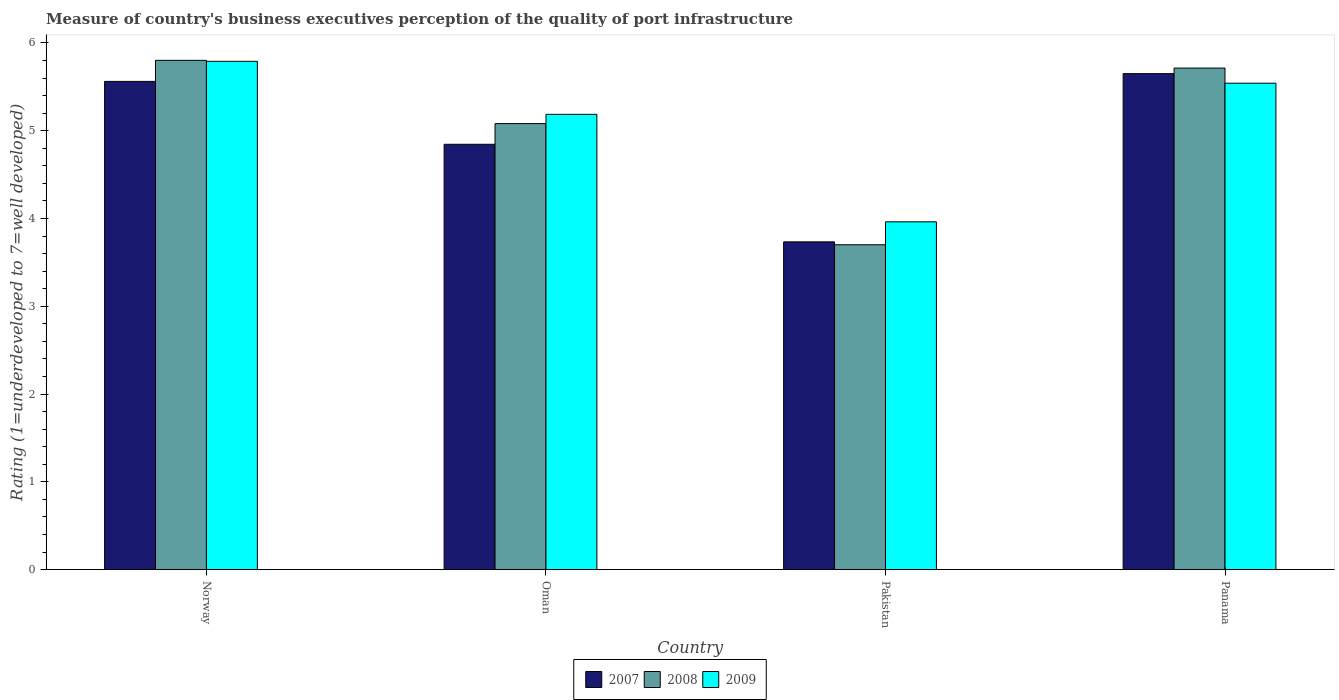Are the number of bars on each tick of the X-axis equal?
Provide a succinct answer. Yes. How many bars are there on the 1st tick from the left?
Offer a very short reply. 3. What is the label of the 4th group of bars from the left?
Make the answer very short. Panama. In how many cases, is the number of bars for a given country not equal to the number of legend labels?
Give a very brief answer. 0. What is the ratings of the quality of port infrastructure in 2007 in Panama?
Your answer should be compact. 5.65. Across all countries, what is the maximum ratings of the quality of port infrastructure in 2009?
Make the answer very short. 5.79. Across all countries, what is the minimum ratings of the quality of port infrastructure in 2008?
Give a very brief answer. 3.7. What is the total ratings of the quality of port infrastructure in 2009 in the graph?
Give a very brief answer. 20.48. What is the difference between the ratings of the quality of port infrastructure in 2007 in Norway and that in Panama?
Give a very brief answer. -0.09. What is the difference between the ratings of the quality of port infrastructure in 2009 in Oman and the ratings of the quality of port infrastructure in 2007 in Norway?
Your response must be concise. -0.38. What is the average ratings of the quality of port infrastructure in 2007 per country?
Provide a succinct answer. 4.95. What is the difference between the ratings of the quality of port infrastructure of/in 2008 and ratings of the quality of port infrastructure of/in 2007 in Pakistan?
Your answer should be compact. -0.03. What is the ratio of the ratings of the quality of port infrastructure in 2008 in Oman to that in Pakistan?
Your response must be concise. 1.37. Is the ratings of the quality of port infrastructure in 2008 in Norway less than that in Panama?
Ensure brevity in your answer.  No. What is the difference between the highest and the second highest ratings of the quality of port infrastructure in 2007?
Offer a very short reply. 0.72. What is the difference between the highest and the lowest ratings of the quality of port infrastructure in 2008?
Give a very brief answer. 2.1. What does the 1st bar from the left in Panama represents?
Provide a succinct answer. 2007. What does the 1st bar from the right in Pakistan represents?
Make the answer very short. 2009. Are all the bars in the graph horizontal?
Give a very brief answer. No. Are the values on the major ticks of Y-axis written in scientific E-notation?
Provide a short and direct response. No. Does the graph contain any zero values?
Your answer should be compact. No. What is the title of the graph?
Provide a short and direct response. Measure of country's business executives perception of the quality of port infrastructure. Does "1971" appear as one of the legend labels in the graph?
Ensure brevity in your answer.  No. What is the label or title of the Y-axis?
Provide a short and direct response. Rating (1=underdeveloped to 7=well developed). What is the Rating (1=underdeveloped to 7=well developed) of 2007 in Norway?
Your answer should be very brief. 5.56. What is the Rating (1=underdeveloped to 7=well developed) in 2008 in Norway?
Your answer should be very brief. 5.8. What is the Rating (1=underdeveloped to 7=well developed) of 2009 in Norway?
Ensure brevity in your answer.  5.79. What is the Rating (1=underdeveloped to 7=well developed) in 2007 in Oman?
Make the answer very short. 4.85. What is the Rating (1=underdeveloped to 7=well developed) of 2008 in Oman?
Keep it short and to the point. 5.08. What is the Rating (1=underdeveloped to 7=well developed) of 2009 in Oman?
Your answer should be compact. 5.19. What is the Rating (1=underdeveloped to 7=well developed) of 2007 in Pakistan?
Your response must be concise. 3.73. What is the Rating (1=underdeveloped to 7=well developed) in 2008 in Pakistan?
Ensure brevity in your answer.  3.7. What is the Rating (1=underdeveloped to 7=well developed) of 2009 in Pakistan?
Give a very brief answer. 3.96. What is the Rating (1=underdeveloped to 7=well developed) of 2007 in Panama?
Provide a succinct answer. 5.65. What is the Rating (1=underdeveloped to 7=well developed) of 2008 in Panama?
Provide a succinct answer. 5.71. What is the Rating (1=underdeveloped to 7=well developed) in 2009 in Panama?
Provide a succinct answer. 5.54. Across all countries, what is the maximum Rating (1=underdeveloped to 7=well developed) in 2007?
Ensure brevity in your answer.  5.65. Across all countries, what is the maximum Rating (1=underdeveloped to 7=well developed) in 2008?
Offer a terse response. 5.8. Across all countries, what is the maximum Rating (1=underdeveloped to 7=well developed) in 2009?
Your answer should be compact. 5.79. Across all countries, what is the minimum Rating (1=underdeveloped to 7=well developed) of 2007?
Provide a short and direct response. 3.73. Across all countries, what is the minimum Rating (1=underdeveloped to 7=well developed) in 2008?
Provide a succinct answer. 3.7. Across all countries, what is the minimum Rating (1=underdeveloped to 7=well developed) in 2009?
Provide a short and direct response. 3.96. What is the total Rating (1=underdeveloped to 7=well developed) in 2007 in the graph?
Provide a short and direct response. 19.79. What is the total Rating (1=underdeveloped to 7=well developed) of 2008 in the graph?
Keep it short and to the point. 20.3. What is the total Rating (1=underdeveloped to 7=well developed) in 2009 in the graph?
Provide a succinct answer. 20.48. What is the difference between the Rating (1=underdeveloped to 7=well developed) of 2007 in Norway and that in Oman?
Your answer should be very brief. 0.72. What is the difference between the Rating (1=underdeveloped to 7=well developed) in 2008 in Norway and that in Oman?
Ensure brevity in your answer.  0.72. What is the difference between the Rating (1=underdeveloped to 7=well developed) in 2009 in Norway and that in Oman?
Make the answer very short. 0.6. What is the difference between the Rating (1=underdeveloped to 7=well developed) in 2007 in Norway and that in Pakistan?
Provide a succinct answer. 1.83. What is the difference between the Rating (1=underdeveloped to 7=well developed) of 2008 in Norway and that in Pakistan?
Your answer should be compact. 2.1. What is the difference between the Rating (1=underdeveloped to 7=well developed) of 2009 in Norway and that in Pakistan?
Give a very brief answer. 1.83. What is the difference between the Rating (1=underdeveloped to 7=well developed) of 2007 in Norway and that in Panama?
Provide a succinct answer. -0.09. What is the difference between the Rating (1=underdeveloped to 7=well developed) in 2008 in Norway and that in Panama?
Provide a short and direct response. 0.09. What is the difference between the Rating (1=underdeveloped to 7=well developed) in 2009 in Norway and that in Panama?
Give a very brief answer. 0.25. What is the difference between the Rating (1=underdeveloped to 7=well developed) in 2007 in Oman and that in Pakistan?
Make the answer very short. 1.11. What is the difference between the Rating (1=underdeveloped to 7=well developed) of 2008 in Oman and that in Pakistan?
Keep it short and to the point. 1.38. What is the difference between the Rating (1=underdeveloped to 7=well developed) in 2009 in Oman and that in Pakistan?
Offer a very short reply. 1.22. What is the difference between the Rating (1=underdeveloped to 7=well developed) of 2007 in Oman and that in Panama?
Offer a terse response. -0.8. What is the difference between the Rating (1=underdeveloped to 7=well developed) of 2008 in Oman and that in Panama?
Make the answer very short. -0.63. What is the difference between the Rating (1=underdeveloped to 7=well developed) of 2009 in Oman and that in Panama?
Make the answer very short. -0.35. What is the difference between the Rating (1=underdeveloped to 7=well developed) of 2007 in Pakistan and that in Panama?
Make the answer very short. -1.92. What is the difference between the Rating (1=underdeveloped to 7=well developed) in 2008 in Pakistan and that in Panama?
Offer a very short reply. -2.01. What is the difference between the Rating (1=underdeveloped to 7=well developed) in 2009 in Pakistan and that in Panama?
Give a very brief answer. -1.58. What is the difference between the Rating (1=underdeveloped to 7=well developed) in 2007 in Norway and the Rating (1=underdeveloped to 7=well developed) in 2008 in Oman?
Offer a terse response. 0.48. What is the difference between the Rating (1=underdeveloped to 7=well developed) of 2007 in Norway and the Rating (1=underdeveloped to 7=well developed) of 2009 in Oman?
Offer a terse response. 0.38. What is the difference between the Rating (1=underdeveloped to 7=well developed) in 2008 in Norway and the Rating (1=underdeveloped to 7=well developed) in 2009 in Oman?
Provide a succinct answer. 0.62. What is the difference between the Rating (1=underdeveloped to 7=well developed) in 2007 in Norway and the Rating (1=underdeveloped to 7=well developed) in 2008 in Pakistan?
Make the answer very short. 1.86. What is the difference between the Rating (1=underdeveloped to 7=well developed) of 2007 in Norway and the Rating (1=underdeveloped to 7=well developed) of 2009 in Pakistan?
Provide a short and direct response. 1.6. What is the difference between the Rating (1=underdeveloped to 7=well developed) in 2008 in Norway and the Rating (1=underdeveloped to 7=well developed) in 2009 in Pakistan?
Make the answer very short. 1.84. What is the difference between the Rating (1=underdeveloped to 7=well developed) in 2007 in Norway and the Rating (1=underdeveloped to 7=well developed) in 2008 in Panama?
Your answer should be very brief. -0.15. What is the difference between the Rating (1=underdeveloped to 7=well developed) in 2007 in Norway and the Rating (1=underdeveloped to 7=well developed) in 2009 in Panama?
Offer a terse response. 0.02. What is the difference between the Rating (1=underdeveloped to 7=well developed) of 2008 in Norway and the Rating (1=underdeveloped to 7=well developed) of 2009 in Panama?
Keep it short and to the point. 0.26. What is the difference between the Rating (1=underdeveloped to 7=well developed) of 2007 in Oman and the Rating (1=underdeveloped to 7=well developed) of 2008 in Pakistan?
Your answer should be very brief. 1.14. What is the difference between the Rating (1=underdeveloped to 7=well developed) of 2007 in Oman and the Rating (1=underdeveloped to 7=well developed) of 2009 in Pakistan?
Give a very brief answer. 0.88. What is the difference between the Rating (1=underdeveloped to 7=well developed) of 2008 in Oman and the Rating (1=underdeveloped to 7=well developed) of 2009 in Pakistan?
Offer a terse response. 1.12. What is the difference between the Rating (1=underdeveloped to 7=well developed) in 2007 in Oman and the Rating (1=underdeveloped to 7=well developed) in 2008 in Panama?
Your answer should be very brief. -0.87. What is the difference between the Rating (1=underdeveloped to 7=well developed) in 2007 in Oman and the Rating (1=underdeveloped to 7=well developed) in 2009 in Panama?
Provide a short and direct response. -0.7. What is the difference between the Rating (1=underdeveloped to 7=well developed) in 2008 in Oman and the Rating (1=underdeveloped to 7=well developed) in 2009 in Panama?
Your answer should be compact. -0.46. What is the difference between the Rating (1=underdeveloped to 7=well developed) in 2007 in Pakistan and the Rating (1=underdeveloped to 7=well developed) in 2008 in Panama?
Offer a terse response. -1.98. What is the difference between the Rating (1=underdeveloped to 7=well developed) in 2007 in Pakistan and the Rating (1=underdeveloped to 7=well developed) in 2009 in Panama?
Keep it short and to the point. -1.81. What is the difference between the Rating (1=underdeveloped to 7=well developed) of 2008 in Pakistan and the Rating (1=underdeveloped to 7=well developed) of 2009 in Panama?
Ensure brevity in your answer.  -1.84. What is the average Rating (1=underdeveloped to 7=well developed) in 2007 per country?
Your answer should be compact. 4.95. What is the average Rating (1=underdeveloped to 7=well developed) in 2008 per country?
Keep it short and to the point. 5.07. What is the average Rating (1=underdeveloped to 7=well developed) in 2009 per country?
Provide a succinct answer. 5.12. What is the difference between the Rating (1=underdeveloped to 7=well developed) in 2007 and Rating (1=underdeveloped to 7=well developed) in 2008 in Norway?
Offer a very short reply. -0.24. What is the difference between the Rating (1=underdeveloped to 7=well developed) in 2007 and Rating (1=underdeveloped to 7=well developed) in 2009 in Norway?
Keep it short and to the point. -0.23. What is the difference between the Rating (1=underdeveloped to 7=well developed) in 2008 and Rating (1=underdeveloped to 7=well developed) in 2009 in Norway?
Offer a terse response. 0.01. What is the difference between the Rating (1=underdeveloped to 7=well developed) in 2007 and Rating (1=underdeveloped to 7=well developed) in 2008 in Oman?
Your response must be concise. -0.24. What is the difference between the Rating (1=underdeveloped to 7=well developed) in 2007 and Rating (1=underdeveloped to 7=well developed) in 2009 in Oman?
Ensure brevity in your answer.  -0.34. What is the difference between the Rating (1=underdeveloped to 7=well developed) in 2008 and Rating (1=underdeveloped to 7=well developed) in 2009 in Oman?
Provide a succinct answer. -0.11. What is the difference between the Rating (1=underdeveloped to 7=well developed) in 2007 and Rating (1=underdeveloped to 7=well developed) in 2008 in Pakistan?
Offer a very short reply. 0.03. What is the difference between the Rating (1=underdeveloped to 7=well developed) in 2007 and Rating (1=underdeveloped to 7=well developed) in 2009 in Pakistan?
Offer a very short reply. -0.23. What is the difference between the Rating (1=underdeveloped to 7=well developed) of 2008 and Rating (1=underdeveloped to 7=well developed) of 2009 in Pakistan?
Offer a terse response. -0.26. What is the difference between the Rating (1=underdeveloped to 7=well developed) in 2007 and Rating (1=underdeveloped to 7=well developed) in 2008 in Panama?
Ensure brevity in your answer.  -0.06. What is the difference between the Rating (1=underdeveloped to 7=well developed) of 2007 and Rating (1=underdeveloped to 7=well developed) of 2009 in Panama?
Your answer should be compact. 0.11. What is the difference between the Rating (1=underdeveloped to 7=well developed) of 2008 and Rating (1=underdeveloped to 7=well developed) of 2009 in Panama?
Offer a very short reply. 0.17. What is the ratio of the Rating (1=underdeveloped to 7=well developed) in 2007 in Norway to that in Oman?
Your response must be concise. 1.15. What is the ratio of the Rating (1=underdeveloped to 7=well developed) of 2008 in Norway to that in Oman?
Make the answer very short. 1.14. What is the ratio of the Rating (1=underdeveloped to 7=well developed) in 2009 in Norway to that in Oman?
Give a very brief answer. 1.12. What is the ratio of the Rating (1=underdeveloped to 7=well developed) of 2007 in Norway to that in Pakistan?
Keep it short and to the point. 1.49. What is the ratio of the Rating (1=underdeveloped to 7=well developed) of 2008 in Norway to that in Pakistan?
Provide a short and direct response. 1.57. What is the ratio of the Rating (1=underdeveloped to 7=well developed) of 2009 in Norway to that in Pakistan?
Make the answer very short. 1.46. What is the ratio of the Rating (1=underdeveloped to 7=well developed) in 2007 in Norway to that in Panama?
Your answer should be very brief. 0.98. What is the ratio of the Rating (1=underdeveloped to 7=well developed) of 2008 in Norway to that in Panama?
Offer a very short reply. 1.02. What is the ratio of the Rating (1=underdeveloped to 7=well developed) in 2009 in Norway to that in Panama?
Give a very brief answer. 1.04. What is the ratio of the Rating (1=underdeveloped to 7=well developed) of 2007 in Oman to that in Pakistan?
Give a very brief answer. 1.3. What is the ratio of the Rating (1=underdeveloped to 7=well developed) of 2008 in Oman to that in Pakistan?
Make the answer very short. 1.37. What is the ratio of the Rating (1=underdeveloped to 7=well developed) in 2009 in Oman to that in Pakistan?
Ensure brevity in your answer.  1.31. What is the ratio of the Rating (1=underdeveloped to 7=well developed) of 2007 in Oman to that in Panama?
Your response must be concise. 0.86. What is the ratio of the Rating (1=underdeveloped to 7=well developed) of 2008 in Oman to that in Panama?
Keep it short and to the point. 0.89. What is the ratio of the Rating (1=underdeveloped to 7=well developed) in 2009 in Oman to that in Panama?
Keep it short and to the point. 0.94. What is the ratio of the Rating (1=underdeveloped to 7=well developed) in 2007 in Pakistan to that in Panama?
Your answer should be compact. 0.66. What is the ratio of the Rating (1=underdeveloped to 7=well developed) of 2008 in Pakistan to that in Panama?
Keep it short and to the point. 0.65. What is the ratio of the Rating (1=underdeveloped to 7=well developed) of 2009 in Pakistan to that in Panama?
Offer a very short reply. 0.72. What is the difference between the highest and the second highest Rating (1=underdeveloped to 7=well developed) of 2007?
Make the answer very short. 0.09. What is the difference between the highest and the second highest Rating (1=underdeveloped to 7=well developed) of 2008?
Ensure brevity in your answer.  0.09. What is the difference between the highest and the second highest Rating (1=underdeveloped to 7=well developed) of 2009?
Offer a very short reply. 0.25. What is the difference between the highest and the lowest Rating (1=underdeveloped to 7=well developed) of 2007?
Make the answer very short. 1.92. What is the difference between the highest and the lowest Rating (1=underdeveloped to 7=well developed) of 2008?
Your response must be concise. 2.1. What is the difference between the highest and the lowest Rating (1=underdeveloped to 7=well developed) in 2009?
Keep it short and to the point. 1.83. 